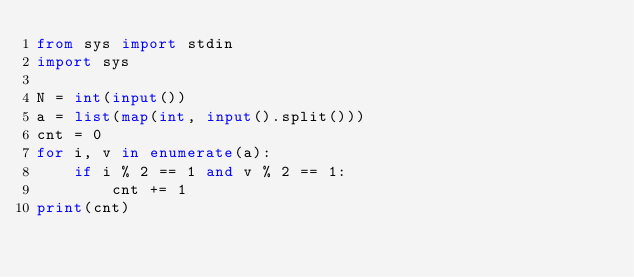Convert code to text. <code><loc_0><loc_0><loc_500><loc_500><_Python_>from sys import stdin
import sys

N = int(input())
a = list(map(int, input().split()))
cnt = 0
for i, v in enumerate(a):
    if i % 2 == 1 and v % 2 == 1:
        cnt += 1
print(cnt)
</code> 